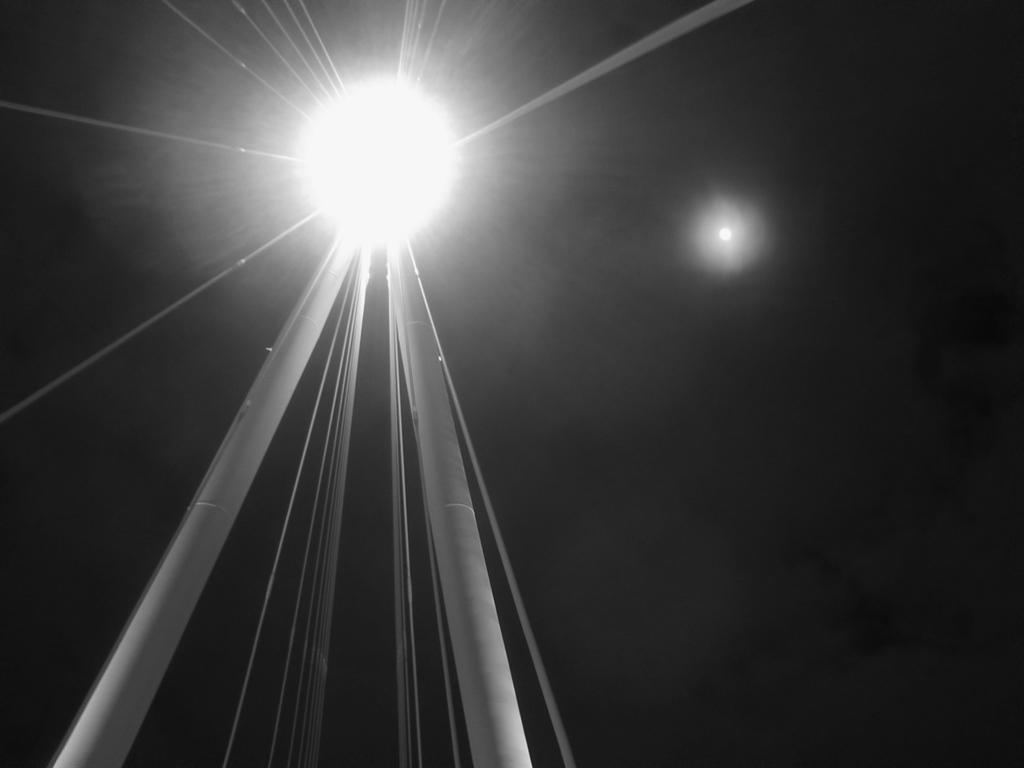What is the main object in the image? There is a light on a pole in the image. What can be seen in the sky in the image? The moon is visible in the sky in the image. How many jellyfish are swimming in the pail in the image? There is no pail or jellyfish present in the image. What is the weather like in the image? The provided facts do not mention the weather, so we cannot determine the weather from the image. 